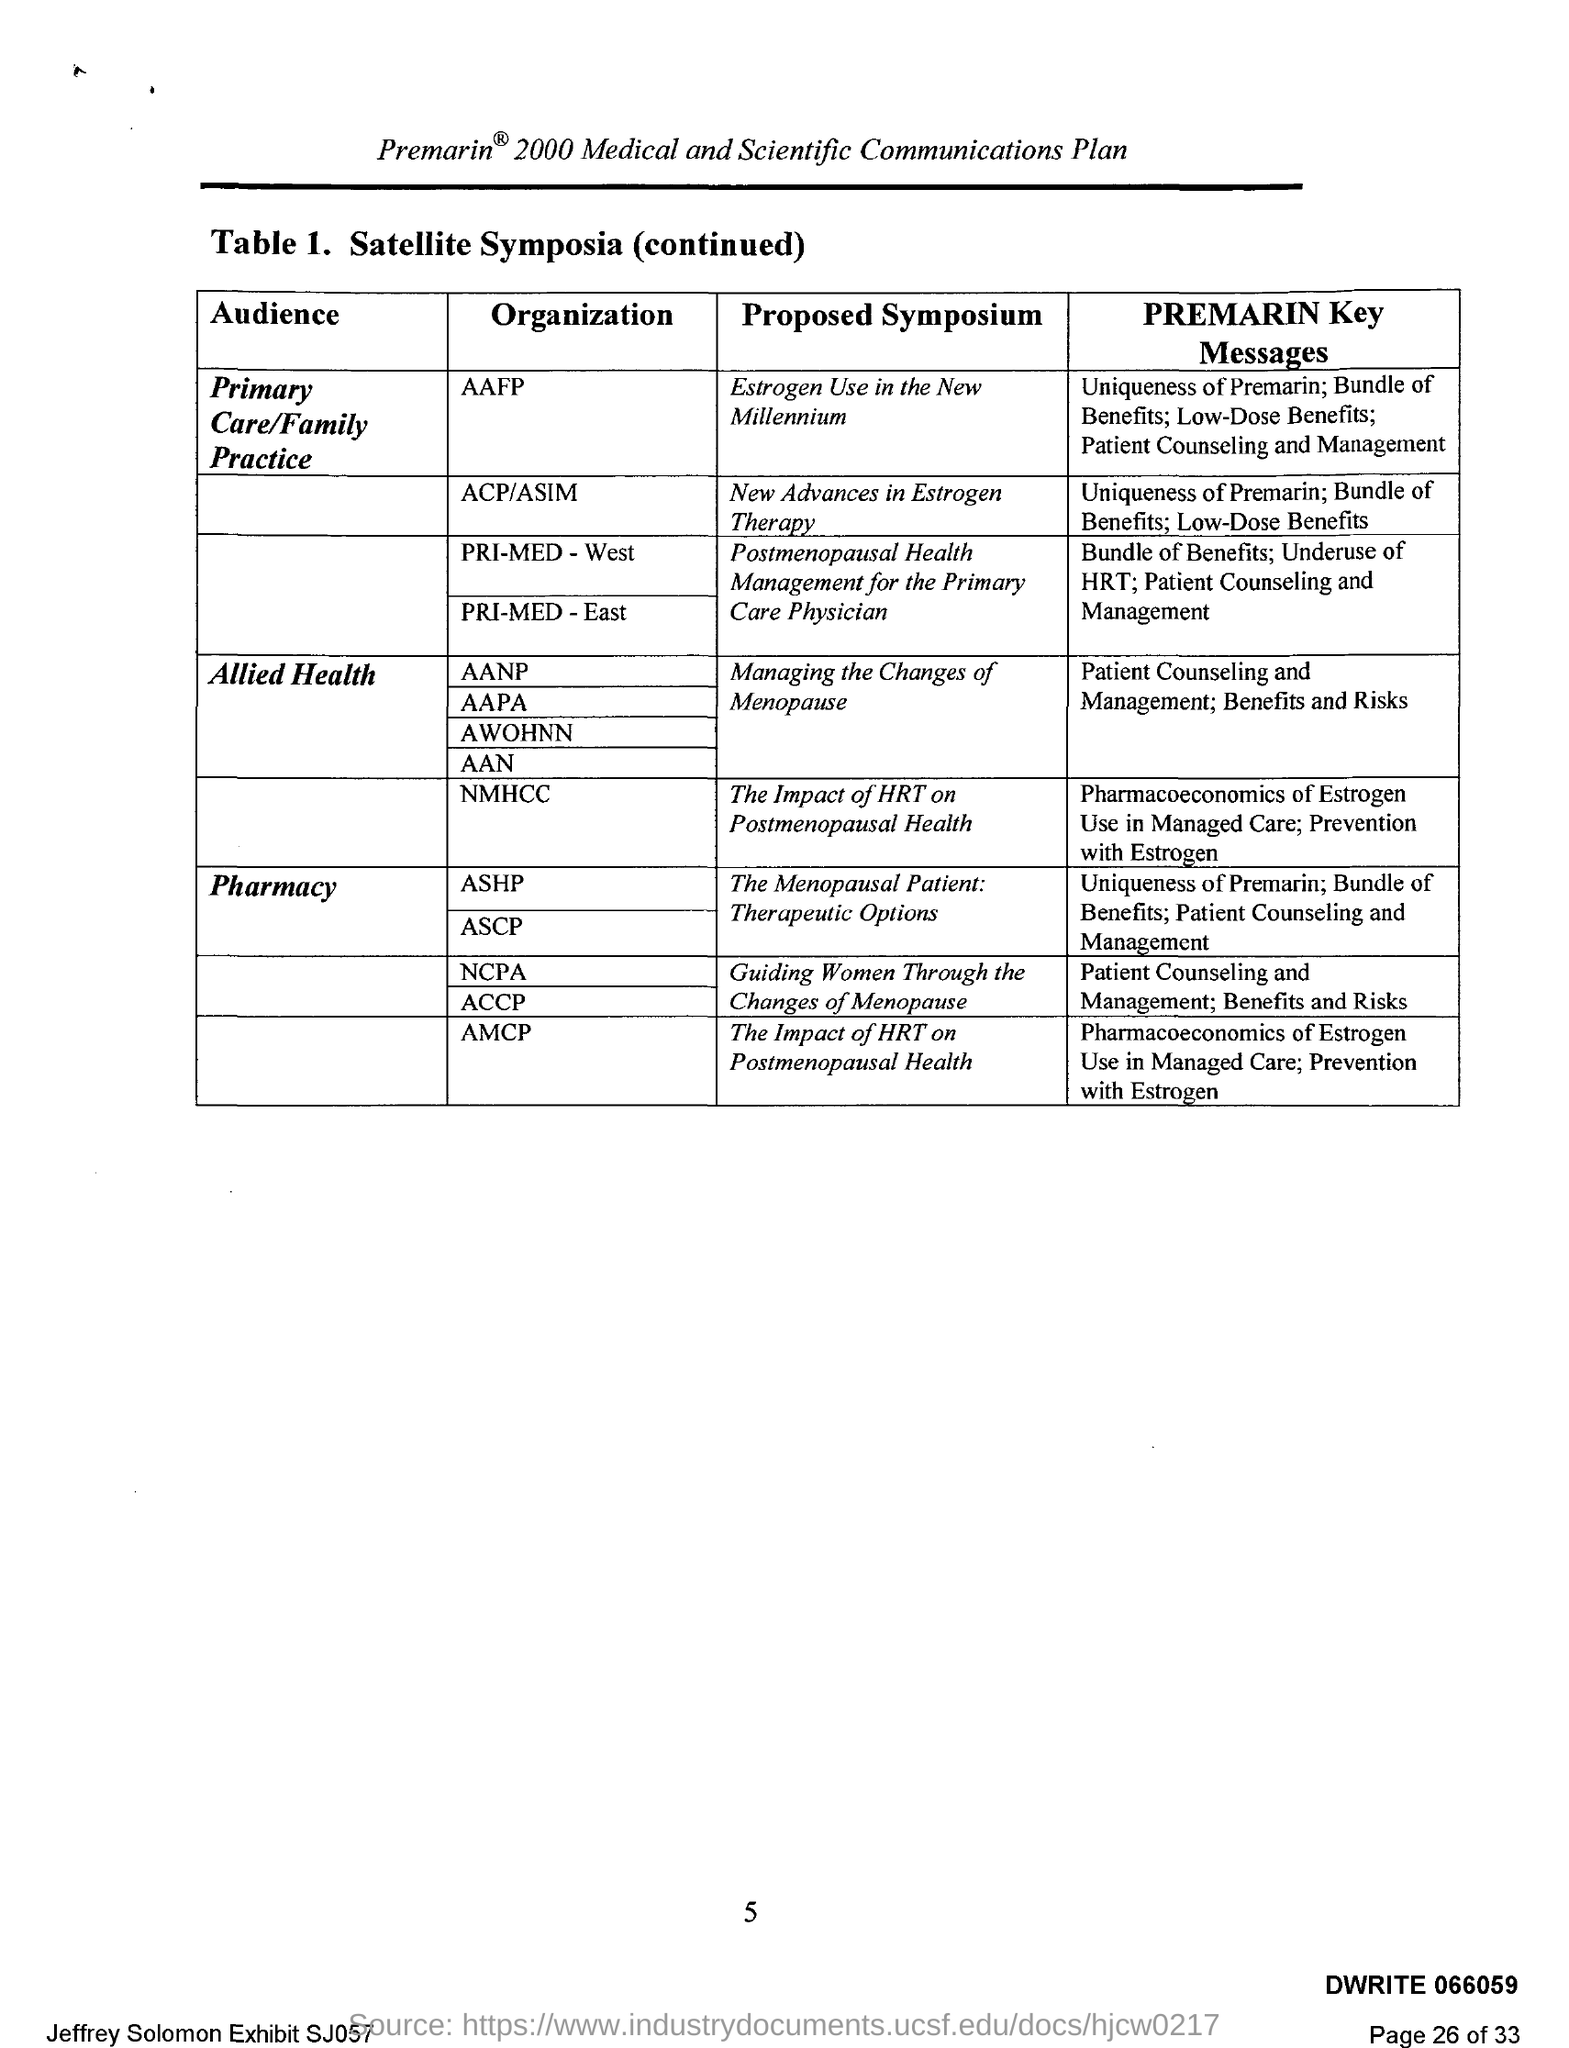Which Organization has Proposed Symposium of "estrogen Use in the New Millenium"?
Give a very brief answer. Aafp. Which Organization has Proposed Symposium of "New Advances in estrogen therapy"?
Your answer should be compact. ACP/ASIM. 